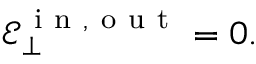<formula> <loc_0><loc_0><loc_500><loc_500>\mathcal { E } _ { \bot } ^ { i n , o u t } = 0 .</formula> 